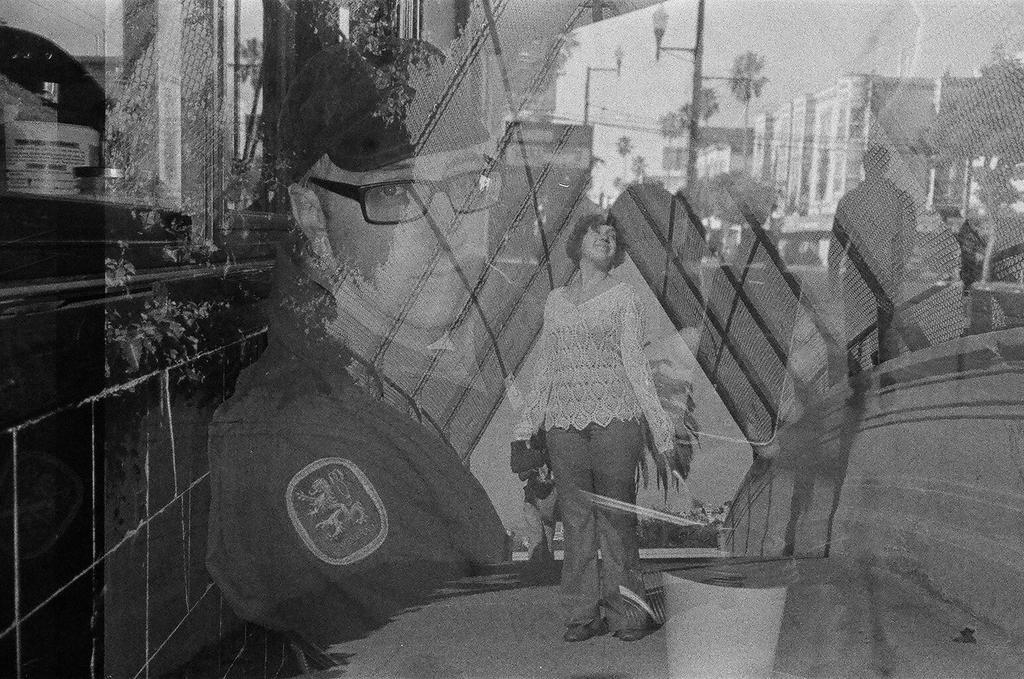Describe this image in one or two sentences. In this image I can see few people, poles, many trees and the buildings. In the background I can see the sky. I can see this is a black and white image. 